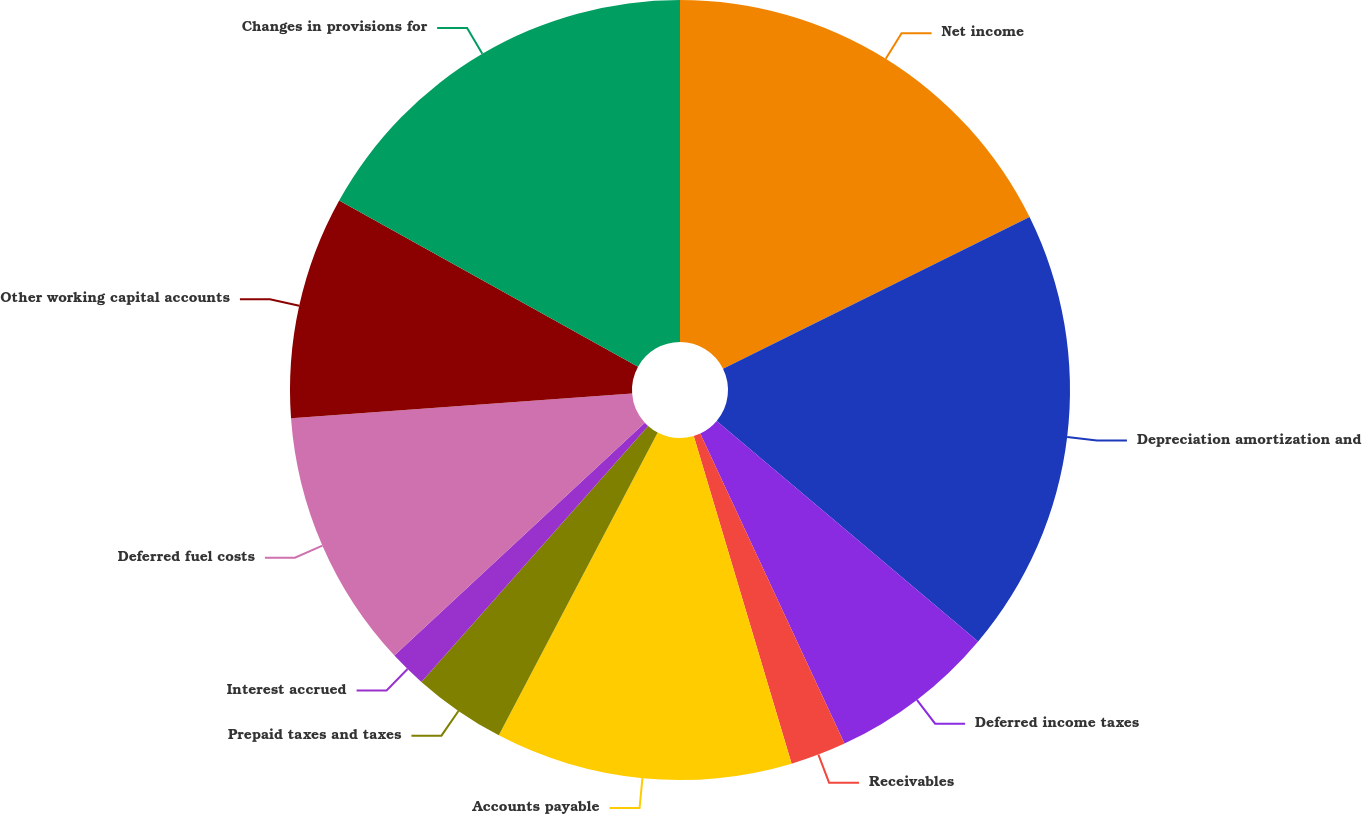Convert chart to OTSL. <chart><loc_0><loc_0><loc_500><loc_500><pie_chart><fcel>Net income<fcel>Depreciation amortization and<fcel>Deferred income taxes<fcel>Receivables<fcel>Accounts payable<fcel>Prepaid taxes and taxes<fcel>Interest accrued<fcel>Deferred fuel costs<fcel>Other working capital accounts<fcel>Changes in provisions for<nl><fcel>17.69%<fcel>18.46%<fcel>6.92%<fcel>2.31%<fcel>12.31%<fcel>3.85%<fcel>1.54%<fcel>10.77%<fcel>9.23%<fcel>16.92%<nl></chart> 